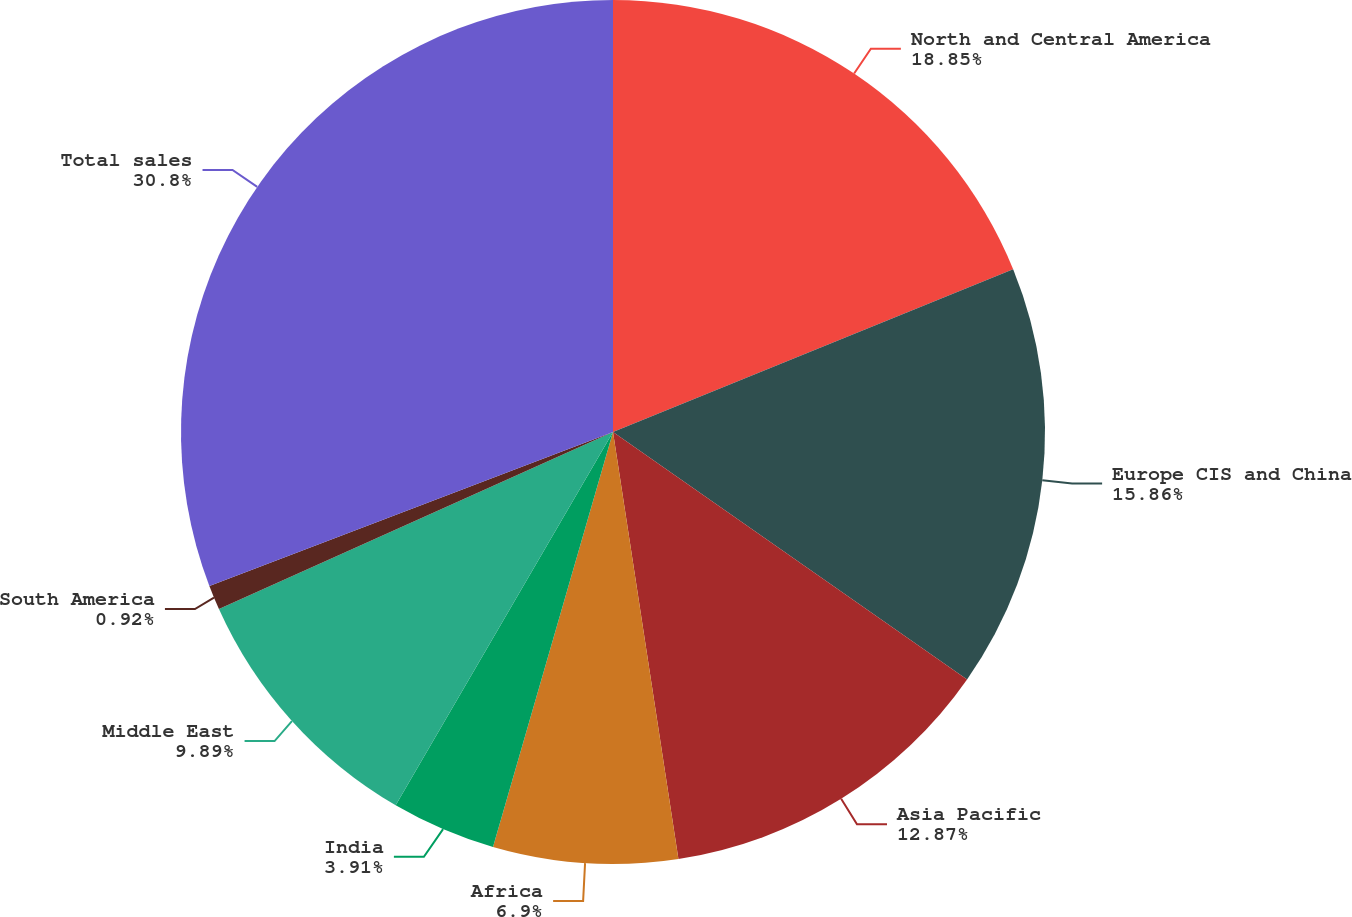Convert chart. <chart><loc_0><loc_0><loc_500><loc_500><pie_chart><fcel>North and Central America<fcel>Europe CIS and China<fcel>Asia Pacific<fcel>Africa<fcel>India<fcel>Middle East<fcel>South America<fcel>Total sales<nl><fcel>18.85%<fcel>15.86%<fcel>12.87%<fcel>6.9%<fcel>3.91%<fcel>9.89%<fcel>0.92%<fcel>30.8%<nl></chart> 